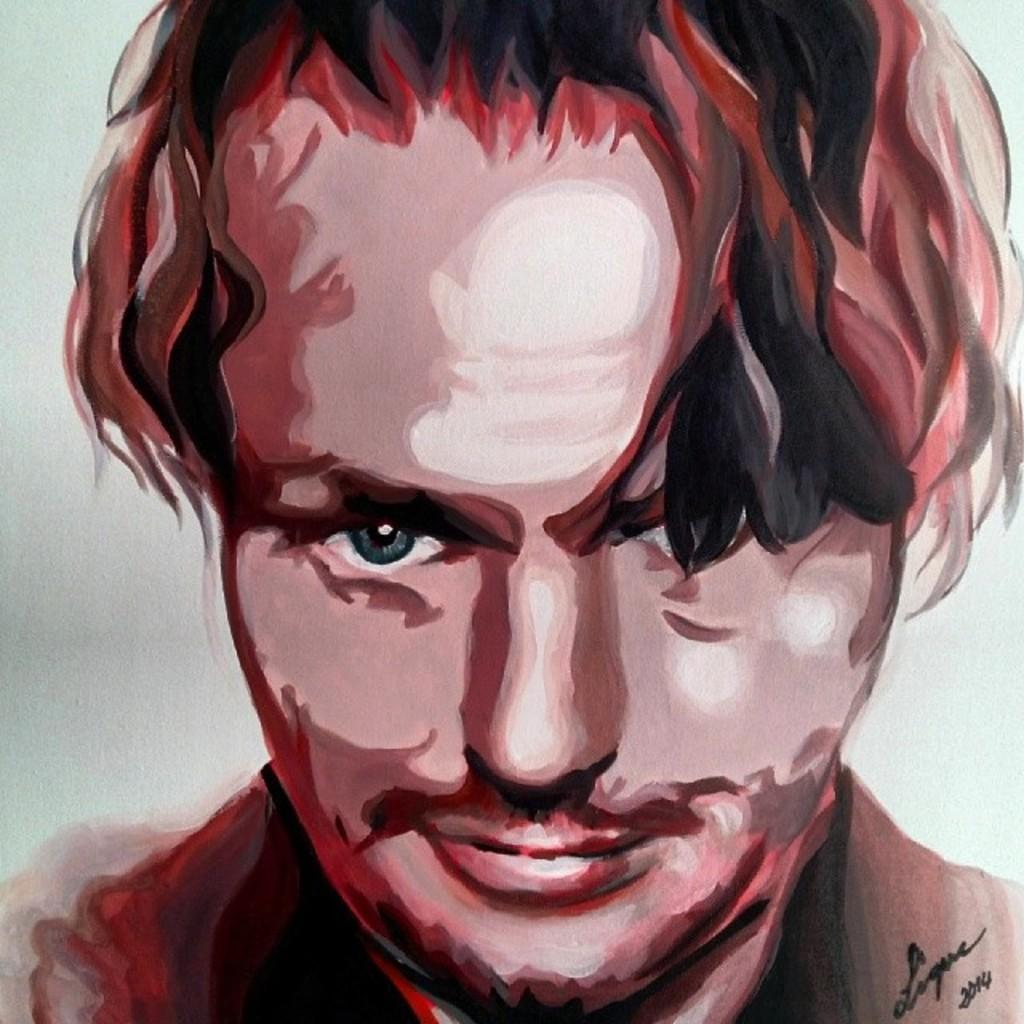What is the main subject of the illustration in the image? The illustration contains a painting. What is the painting depicting? The painting depicts a man. What color is the background of the painting? The background of the painting is white in color. How many hands does the man have in the painting? The provided facts do not mention the number of hands the man has in the painting, so we cannot definitively answer this question. 